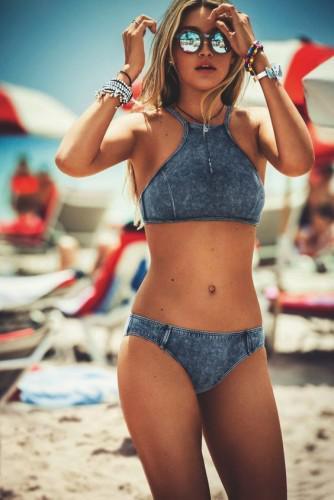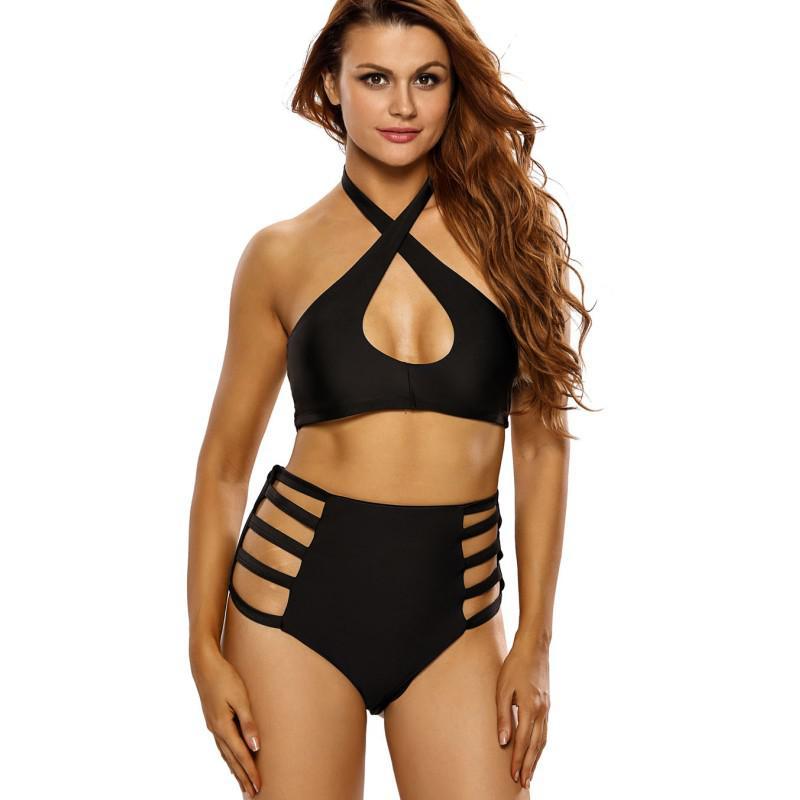The first image is the image on the left, the second image is the image on the right. Assess this claim about the two images: "All models wear bikinis with matching color tops and bottoms.". Correct or not? Answer yes or no. Yes. 